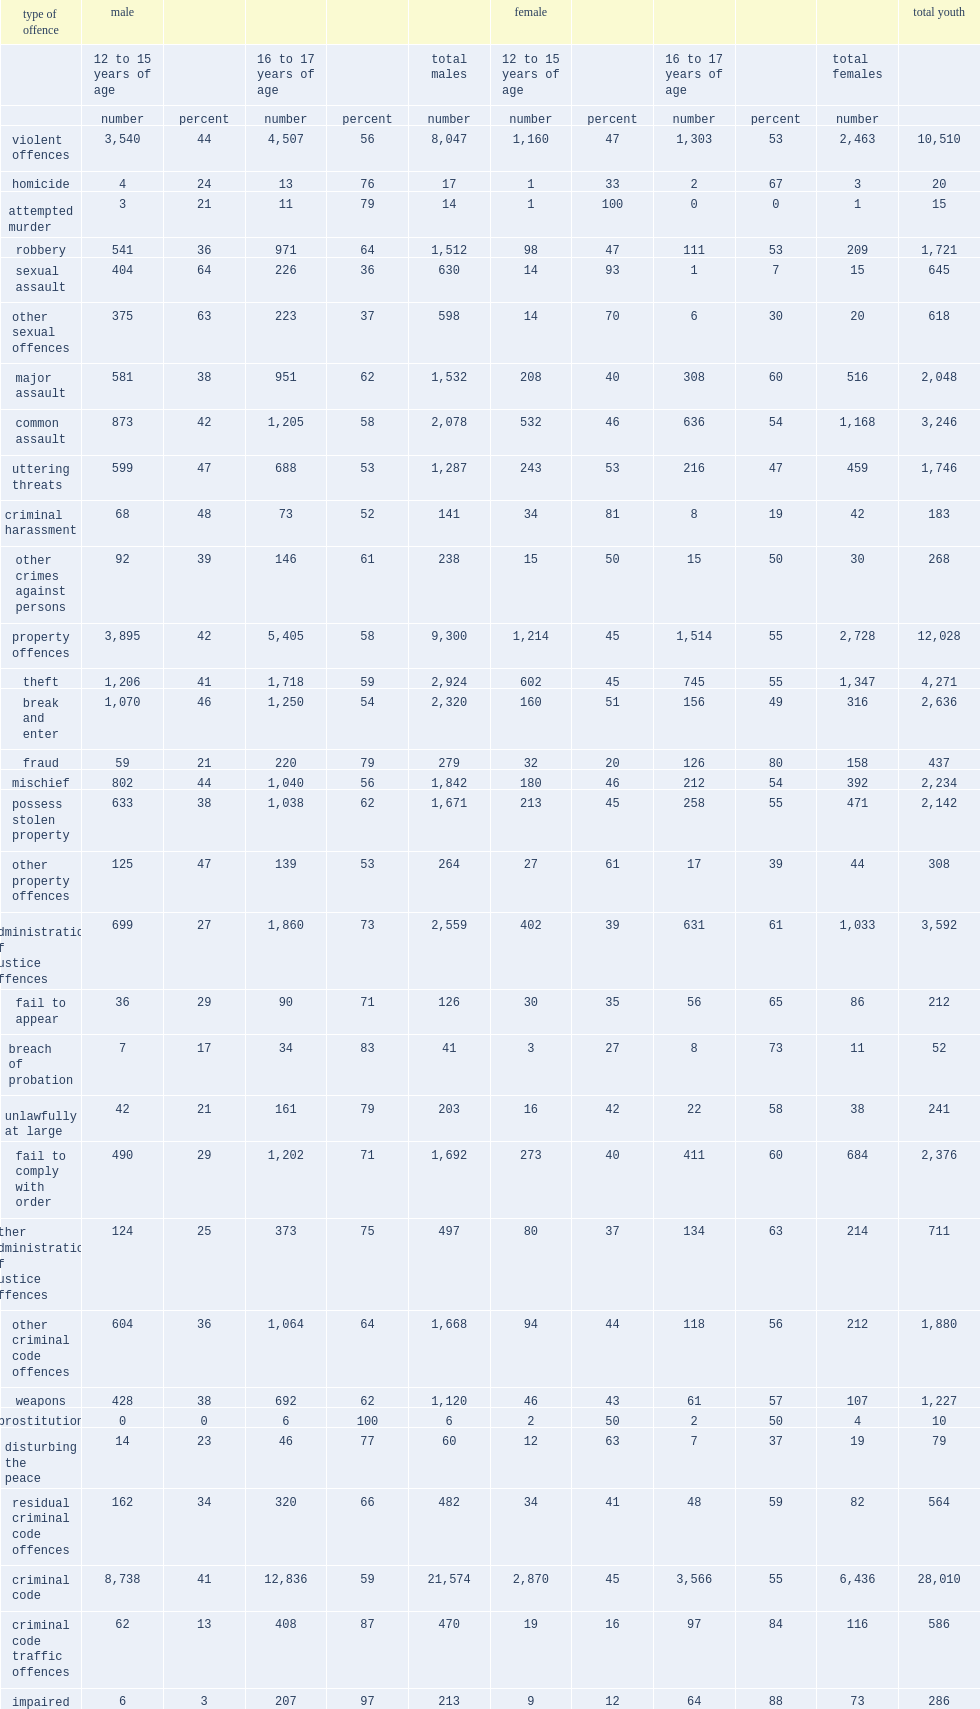Which age group of male accused have a higher proportion for sexual assault? 12 to 15 years of age. What is the percentage of all accused persons in youth court are male? 0.775976. What is the percentage of youth accused of failure to appear were female? 0.40566. What is the percentage of youth accused of prostitution to appear were female? 0.4. What is the percentage of youth accused of fraud to appear were female? 0.361556. What is the percentage of youth accused of sexual assault to appear were female? 0.023256. What is the percentage of youth accused of other sexual offences to appear were female? 0.032362. What is the percentage of youth accused of attempted murder to appear were female? 0.066667. 